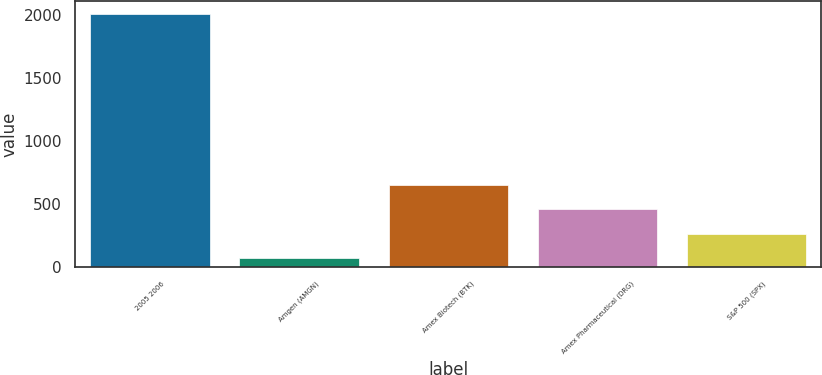Convert chart. <chart><loc_0><loc_0><loc_500><loc_500><bar_chart><fcel>2005 2006<fcel>Amgen (AMGN)<fcel>Amex Biotech (BTK)<fcel>Amex Pharmaceutical (DRG)<fcel>S&P 500 (SPX)<nl><fcel>2009<fcel>71.73<fcel>652.92<fcel>459.19<fcel>265.46<nl></chart> 